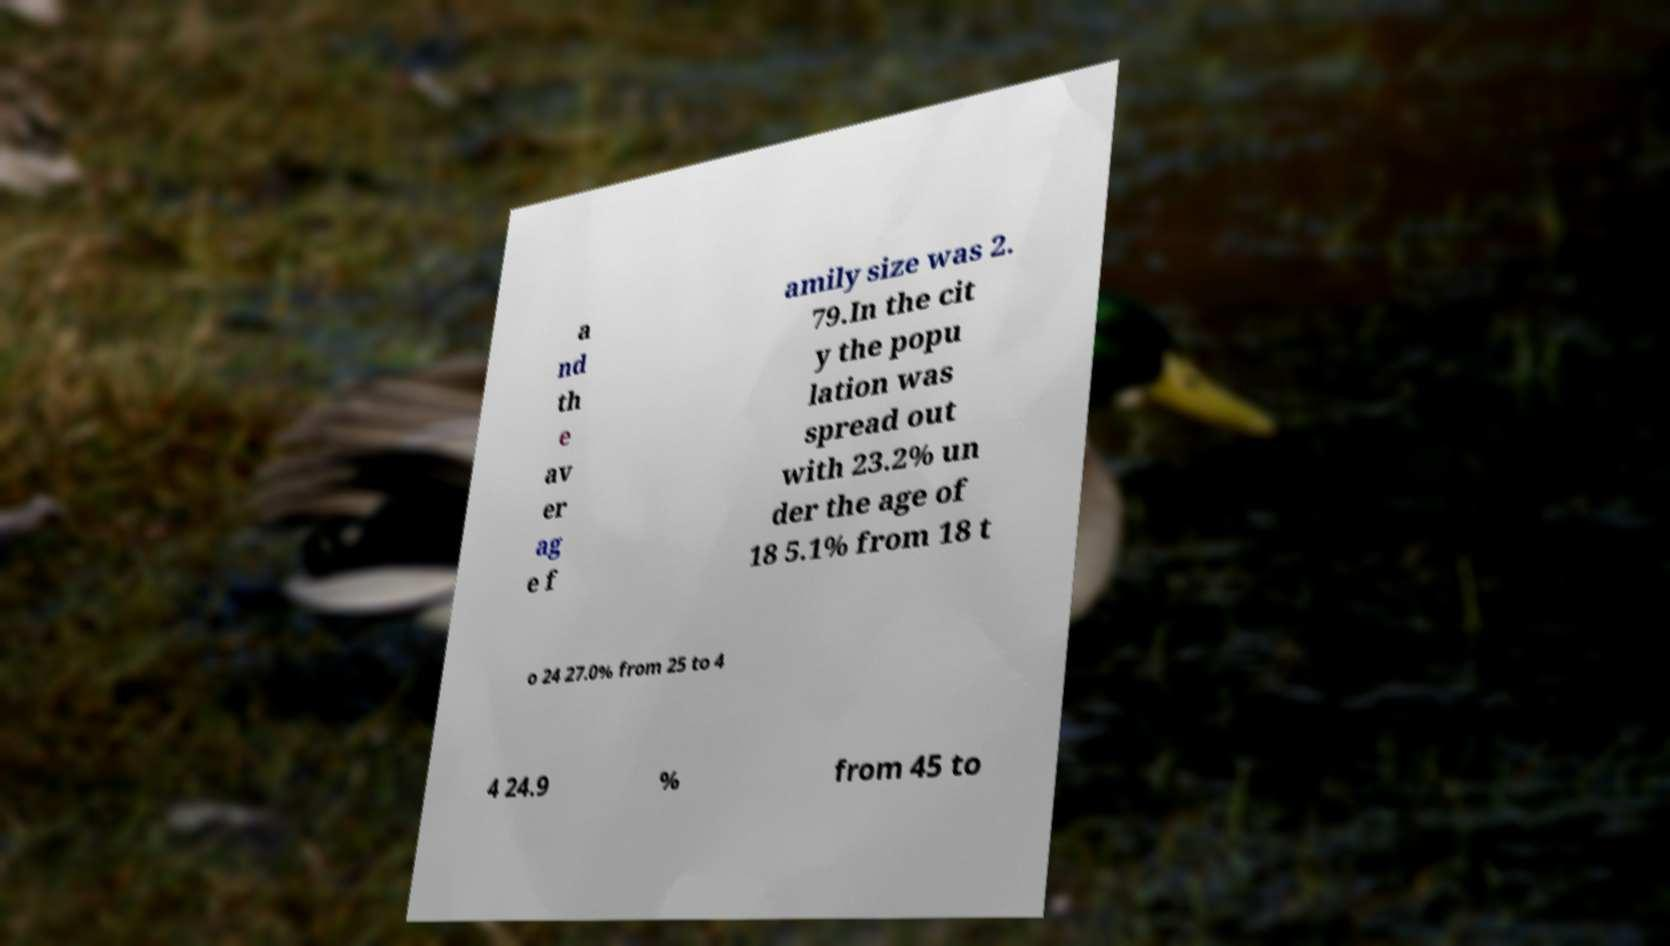Please read and relay the text visible in this image. What does it say? a nd th e av er ag e f amily size was 2. 79.In the cit y the popu lation was spread out with 23.2% un der the age of 18 5.1% from 18 t o 24 27.0% from 25 to 4 4 24.9 % from 45 to 